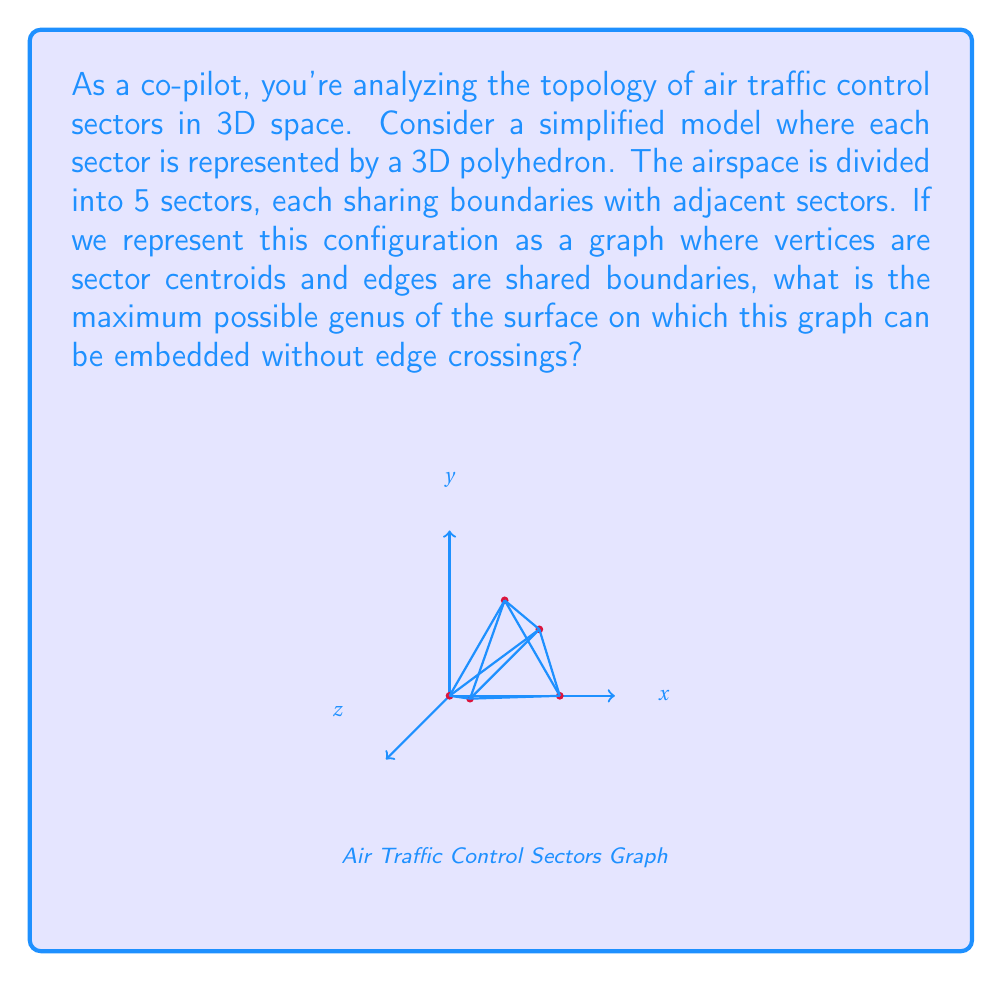Can you answer this question? To solve this problem, we'll use the Euler characteristic and the relationship between genus and graph embedding:

1) First, recall the Euler characteristic formula for a graph embedded on a surface:
   $$ \chi = V - E + F $$
   where $\chi$ is the Euler characteristic, $V$ is the number of vertices, $E$ is the number of edges, and $F$ is the number of faces.

2) For a surface with genus $g$, the Euler characteristic is given by:
   $$ \chi = 2 - 2g $$

3) In our graph:
   - We have 5 vertices (V = 5), representing the centroids of the 5 sectors.
   - The maximum number of edges in a graph with 5 vertices is $\binom{5}{2} = 10$ (E = 10).

4) To find the maximum genus, we need to minimize $F$. The minimum number of faces is 1 (the external face).

5) Substituting these values into the Euler characteristic formula:
   $$ 2 - 2g = 5 - 10 + 1 $$
   $$ 2 - 2g = -4 $$
   $$ -2g = -6 $$
   $$ g = 3 $$

6) Therefore, the maximum possible genus of the surface on which this graph can be embedded without edge crossings is 3.

This corresponds to a surface topologically equivalent to a pretzel with three holes, also known as a 3-torus.
Answer: 3 